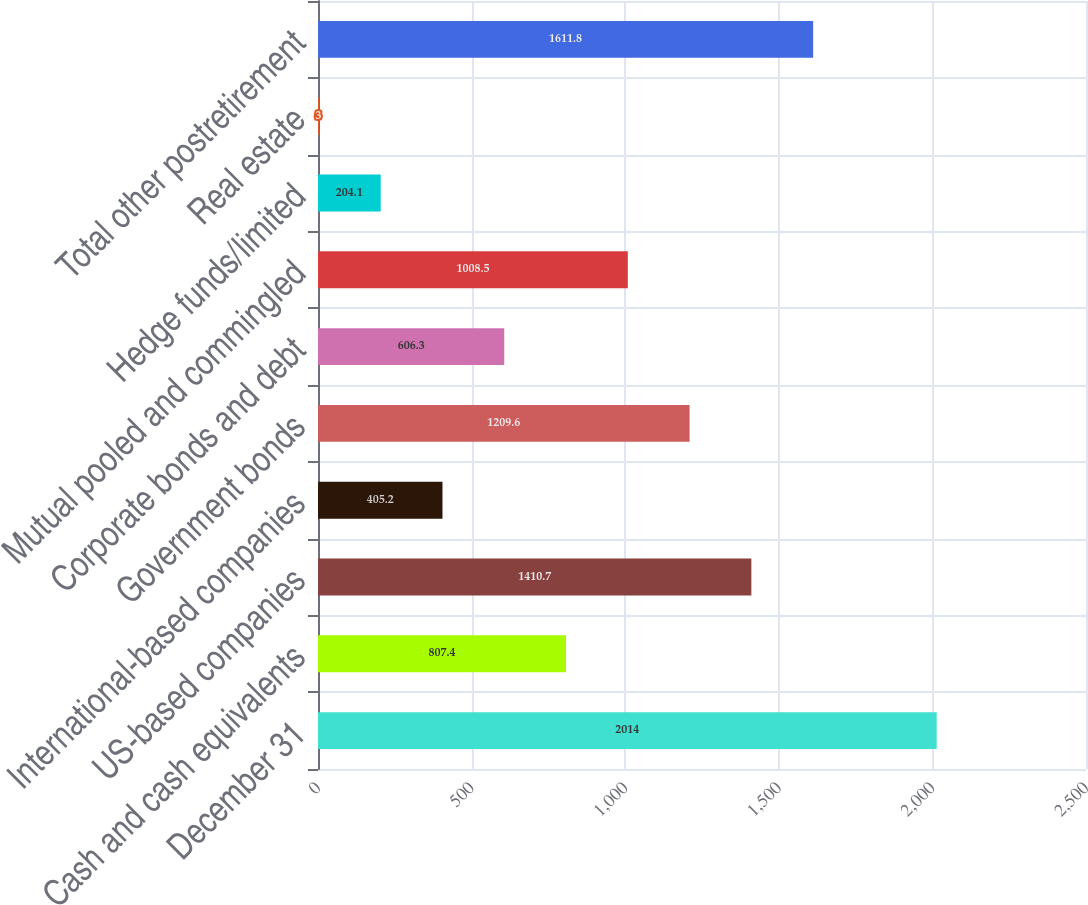Convert chart. <chart><loc_0><loc_0><loc_500><loc_500><bar_chart><fcel>December 31<fcel>Cash and cash equivalents<fcel>US-based companies<fcel>International-based companies<fcel>Government bonds<fcel>Corporate bonds and debt<fcel>Mutual pooled and commingled<fcel>Hedge funds/limited<fcel>Real estate<fcel>Total other postretirement<nl><fcel>2014<fcel>807.4<fcel>1410.7<fcel>405.2<fcel>1209.6<fcel>606.3<fcel>1008.5<fcel>204.1<fcel>3<fcel>1611.8<nl></chart> 